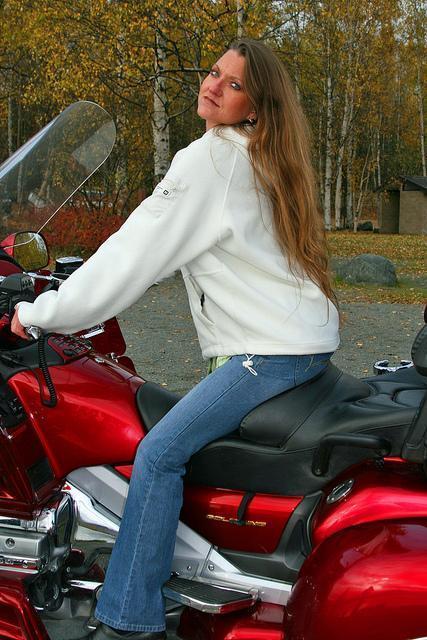How many people in the photo?
Give a very brief answer. 1. How many cars are in the picture?
Give a very brief answer. 0. 